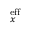<formula> <loc_0><loc_0><loc_500><loc_500>_ { x } ^ { e f f }</formula> 